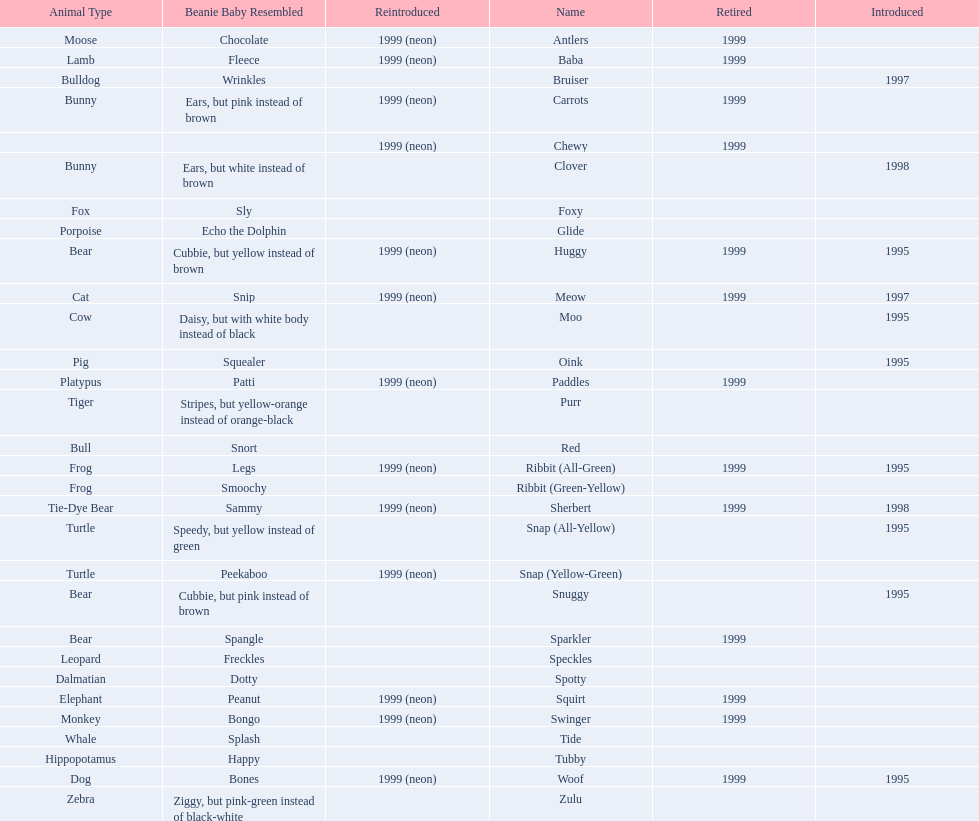What is the number of frog pillow pals? 2. 